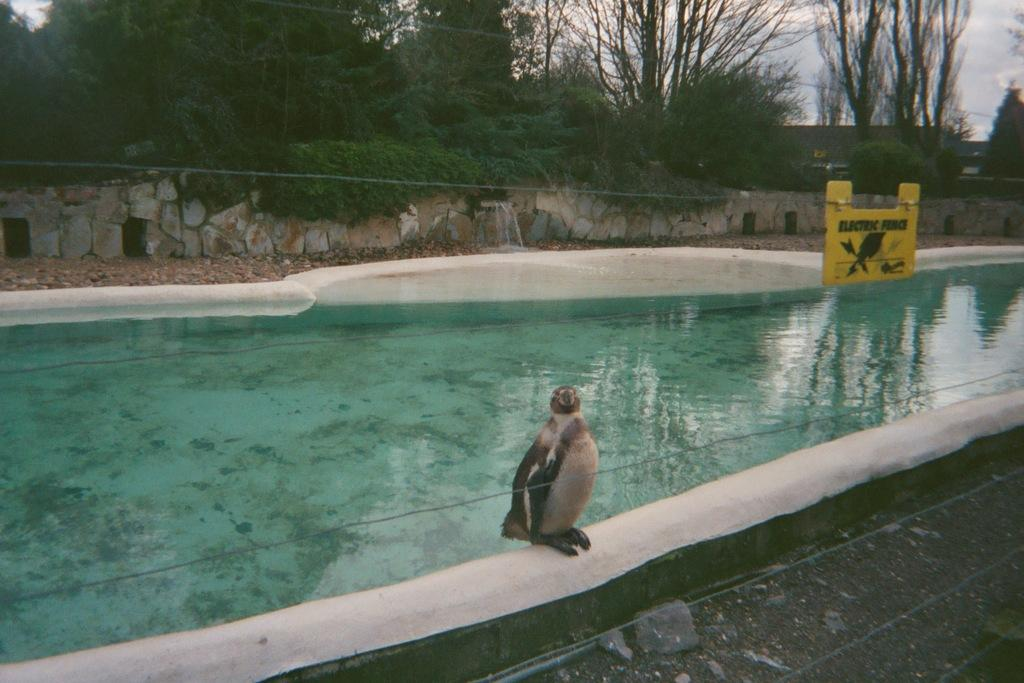What animal is present in the picture? There is a penguin in the picture. What is visible in the background of the picture? There is a pond, rocks, and trees in the backdrop of the picture. What type of barrier can be seen in the picture? There is an electric fence in the picture. What is the condition of the sky in the picture? The sky is clear in the picture. How many toes can be seen on the penguin in the picture? It is difficult to determine the exact number of toes on the penguin in the picture, as the image may not show the penguin's feet in detail. --- Facts: 1. There is a person holding a camera in the image. 2. The person is wearing a hat. 3. There is a building in the background of the image. 4. The person is standing on a bridge. 5. The bridge is over a river. Absurd Topics: parrot, bicycle, sand Conversation: What is the person in the image doing? The person in the image is holding a camera. What type of headwear is the person wearing? The person is wearing a hat. What can be seen in the background of the image? There is a building in the background of the image. Where is the person standing in the image? The person is standing on a bridge. What is the bridge crossing in the image? The bridge is crossing over a river. Reasoning: Let's think step by step in order to produce the conversation. We start by identifying the main subject of the image, which is the person holding a camera. Then, we describe the person's attire, including the hat. Next, we mention the background of the image, which includes a building. Finally, we describe the location of the person, which is on a bridge crossing over a river. Absurd Question/Answer: Can you see a parrot riding a bicycle on the sand in the image? No, there is no parrot, bicycle, or sand present in the image. 